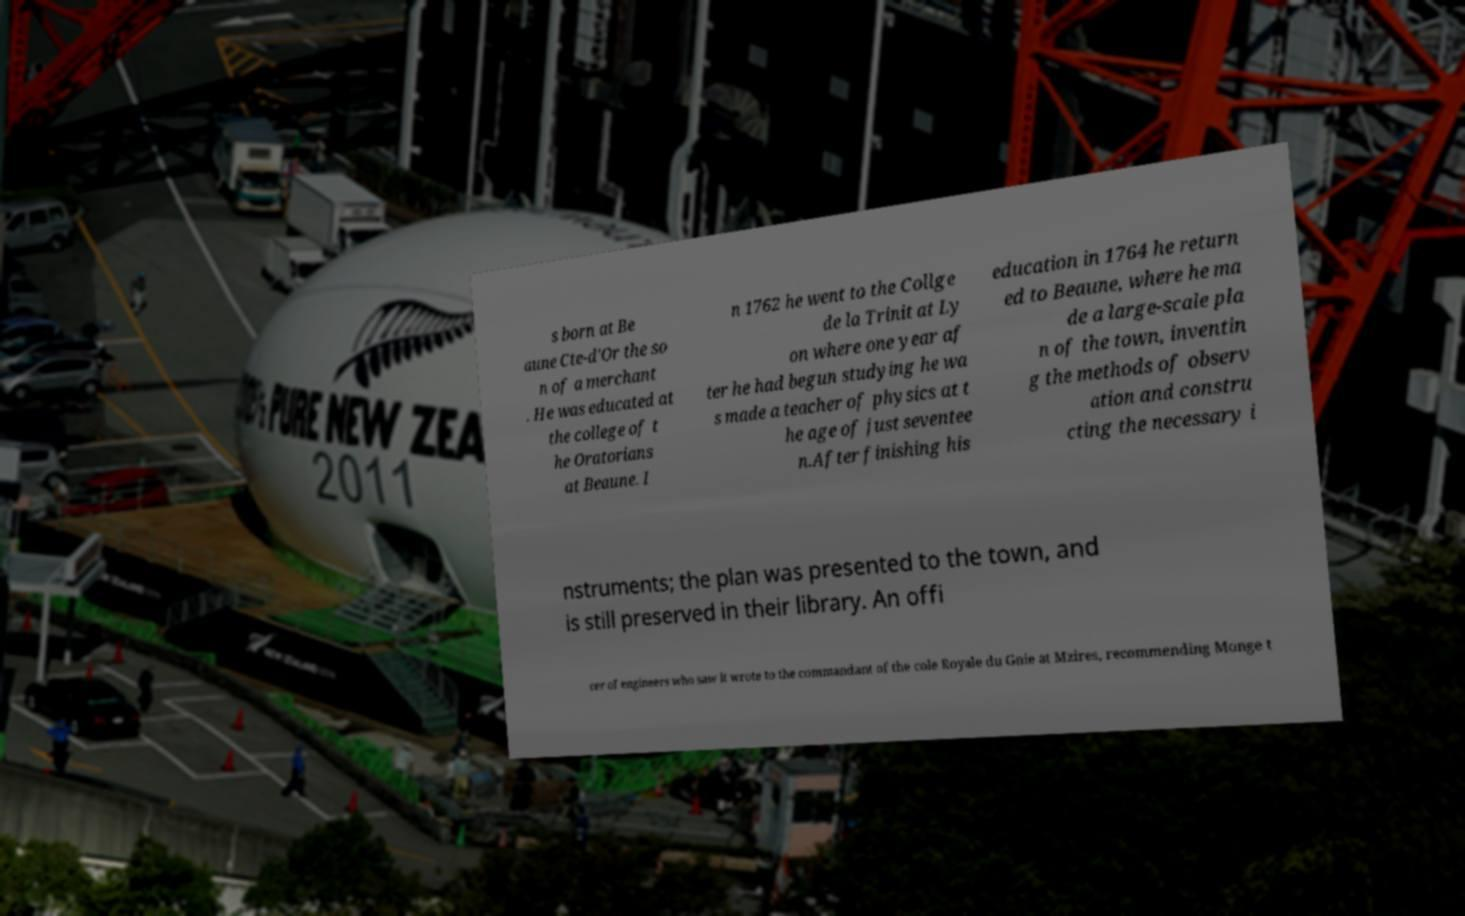Can you accurately transcribe the text from the provided image for me? s born at Be aune Cte-d'Or the so n of a merchant . He was educated at the college of t he Oratorians at Beaune. I n 1762 he went to the Collge de la Trinit at Ly on where one year af ter he had begun studying he wa s made a teacher of physics at t he age of just seventee n.After finishing his education in 1764 he return ed to Beaune, where he ma de a large-scale pla n of the town, inventin g the methods of observ ation and constru cting the necessary i nstruments; the plan was presented to the town, and is still preserved in their library. An offi cer of engineers who saw it wrote to the commandant of the cole Royale du Gnie at Mzires, recommending Monge t 